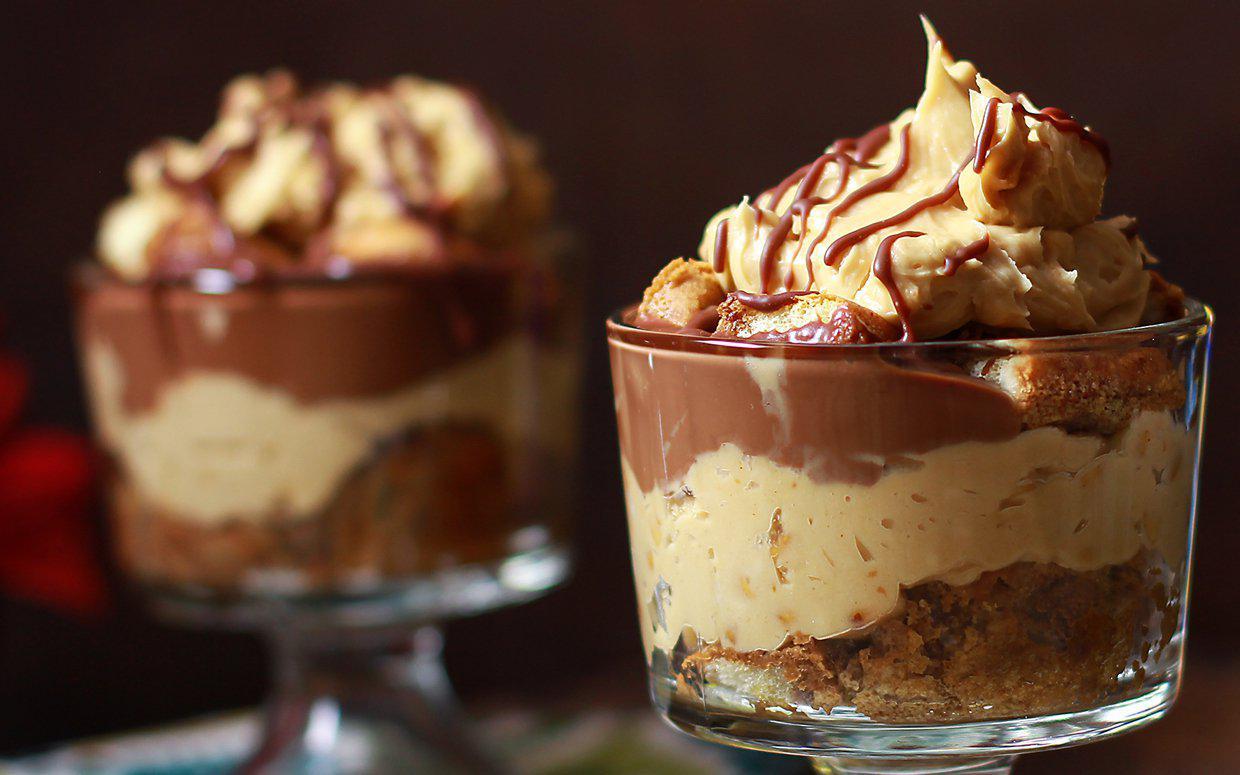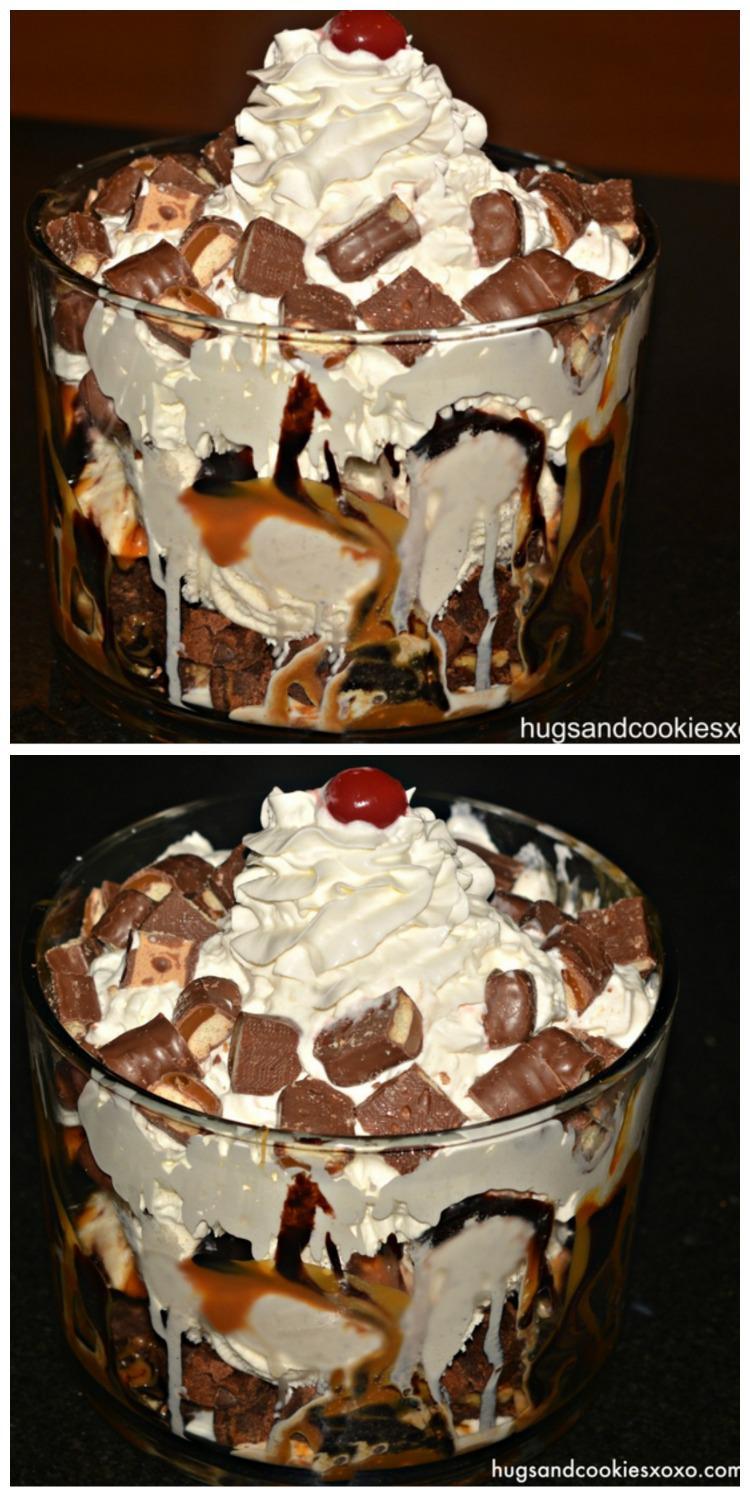The first image is the image on the left, the second image is the image on the right. Considering the images on both sides, is "Some of the desserts are dished out in individual servings." valid? Answer yes or no. Yes. The first image is the image on the left, the second image is the image on the right. Given the left and right images, does the statement "No more than one dessert is shown on each picture." hold true? Answer yes or no. No. 